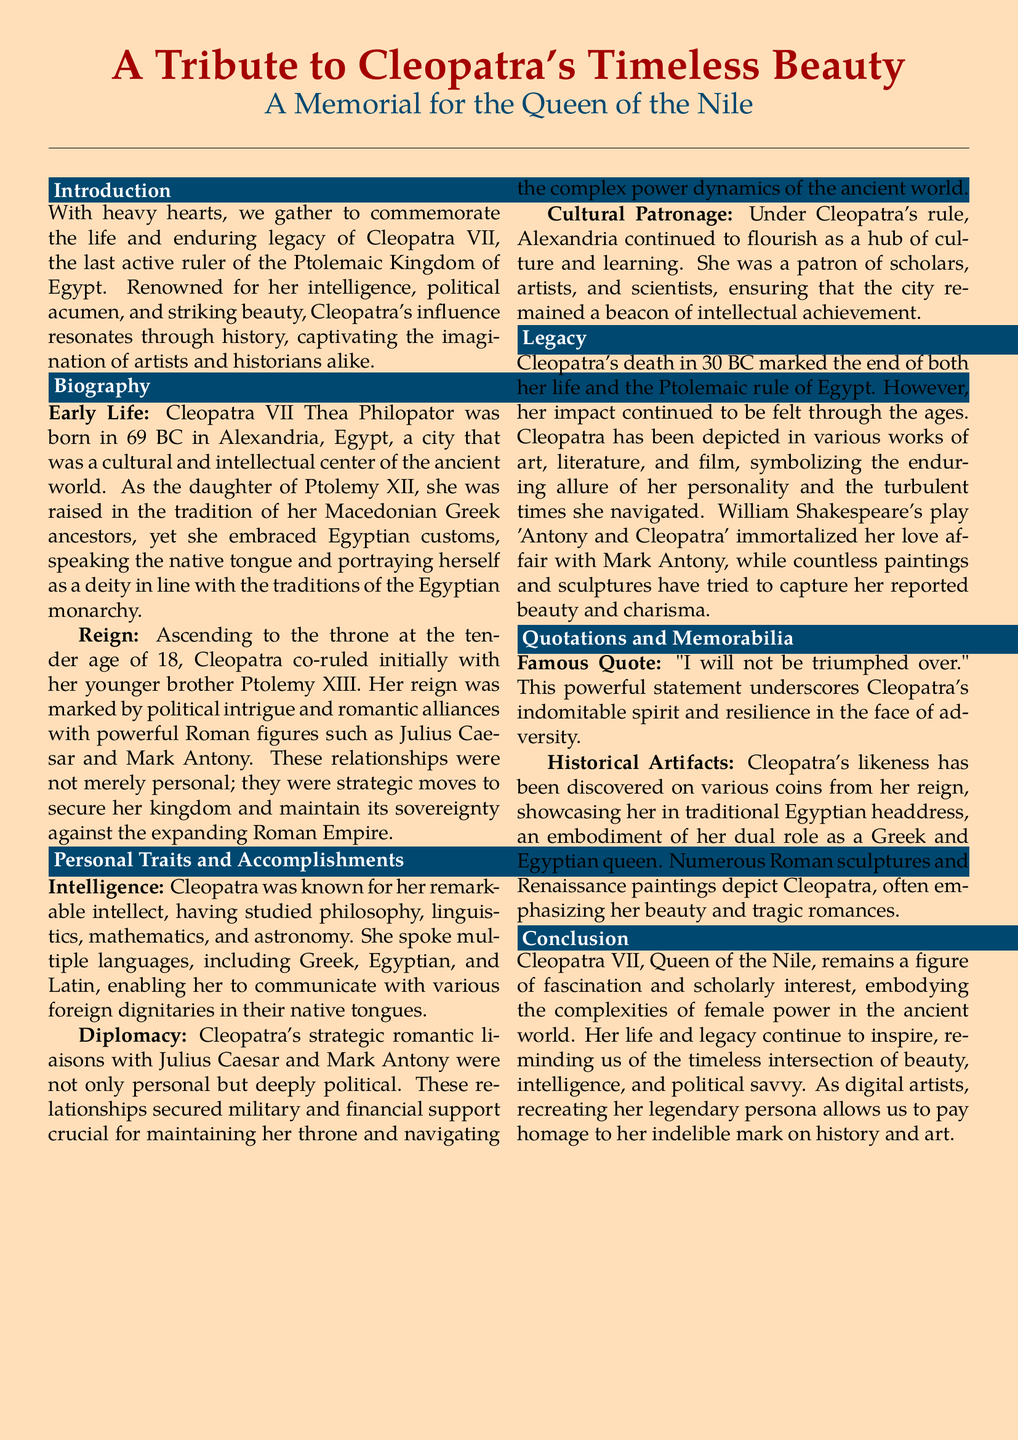what year was Cleopatra born? Cleopatra was born in 69 BC, as mentioned in the biography section.
Answer: 69 BC what is Cleopatra known for besides her beauty? The document states that Cleopatra is also known for her intelligence and political acumen.
Answer: Intelligence and political acumen who were Cleopatra's notable romantic alliances? The document lists Julius Caesar and Mark Antony as powerful Roman figures with whom Cleopatra had romantic alliances.
Answer: Julius Caesar and Mark Antony what was Cleopatra's famous quote? The document quotes Cleopatra's statement "I will not be triumphed over" as a representation of her spirit.
Answer: "I will not be triumphed over." what role did Alexandria play during Cleopatra's reign? Alexandria served as a hub of culture and learning, as per the document.
Answer: Cultural and intellectual hub how did Cleopatra's relationships influence her reign? The document explains that her relationships secured military and financial support, essential for maintaining her throne.
Answer: Secured military and financial support what marked the end of Cleopatra's life and rule? Cleopatra's death in 30 BC marked the end of her life and the Ptolemaic rule.
Answer: Death in 30 BC what does Cleopatra symbolize in art and literature? According to the document, Cleopatra symbolizes the enduring allure of her personality and turbulent times.
Answer: Enduring allure and turbulent times which Shakespeare play immortalized Cleopatra? The memorial mentions that Shakespeare's play 'Antony and Cleopatra' depicts her love affair with Mark Antony.
Answer: 'Antony and Cleopatra' 